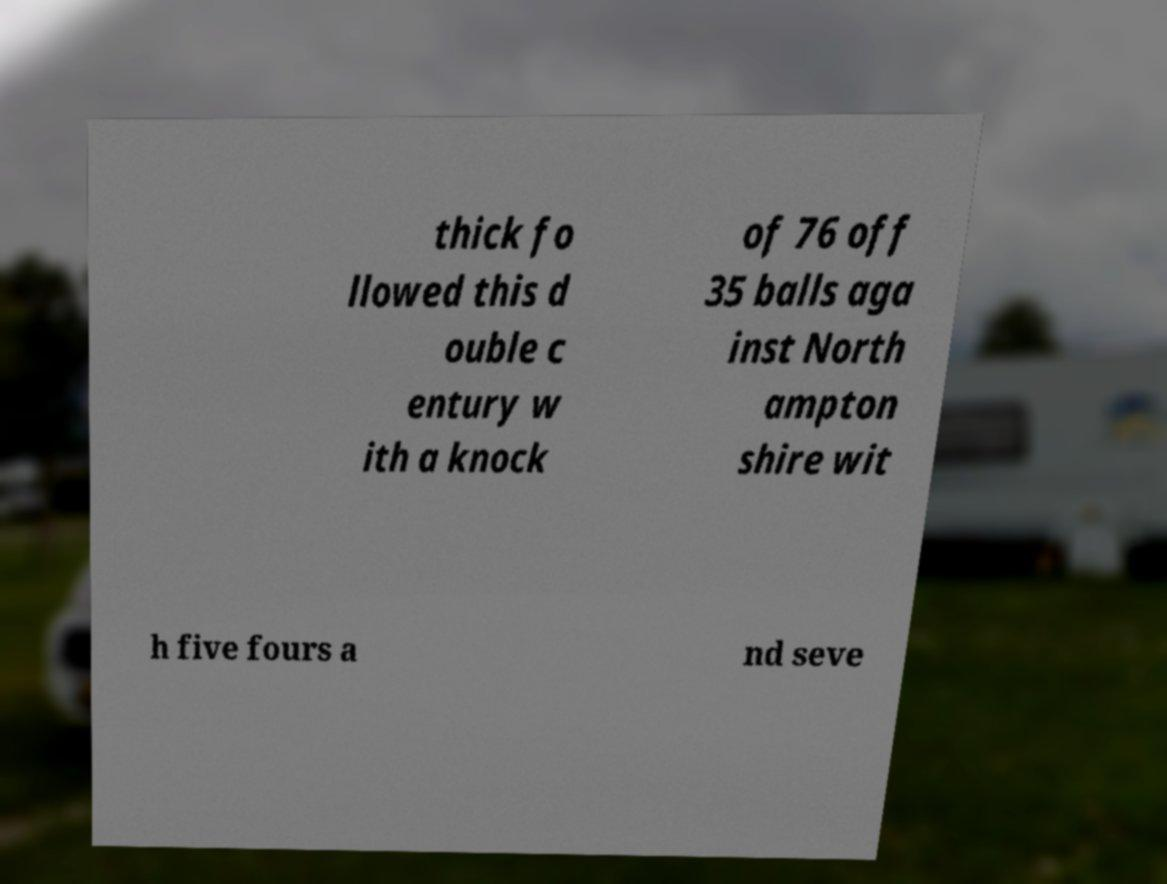Could you extract and type out the text from this image? thick fo llowed this d ouble c entury w ith a knock of 76 off 35 balls aga inst North ampton shire wit h five fours a nd seve 